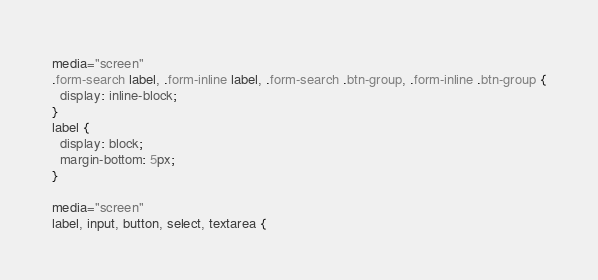Convert code to text. <code><loc_0><loc_0><loc_500><loc_500><_CSS_>media="screen"
.form-search label, .form-inline label, .form-search .btn-group, .form-inline .btn-group {
  display: inline-block;
}
label {
  display: block;
  margin-bottom: 5px;
}

media="screen"
label, input, button, select, textarea {</code> 